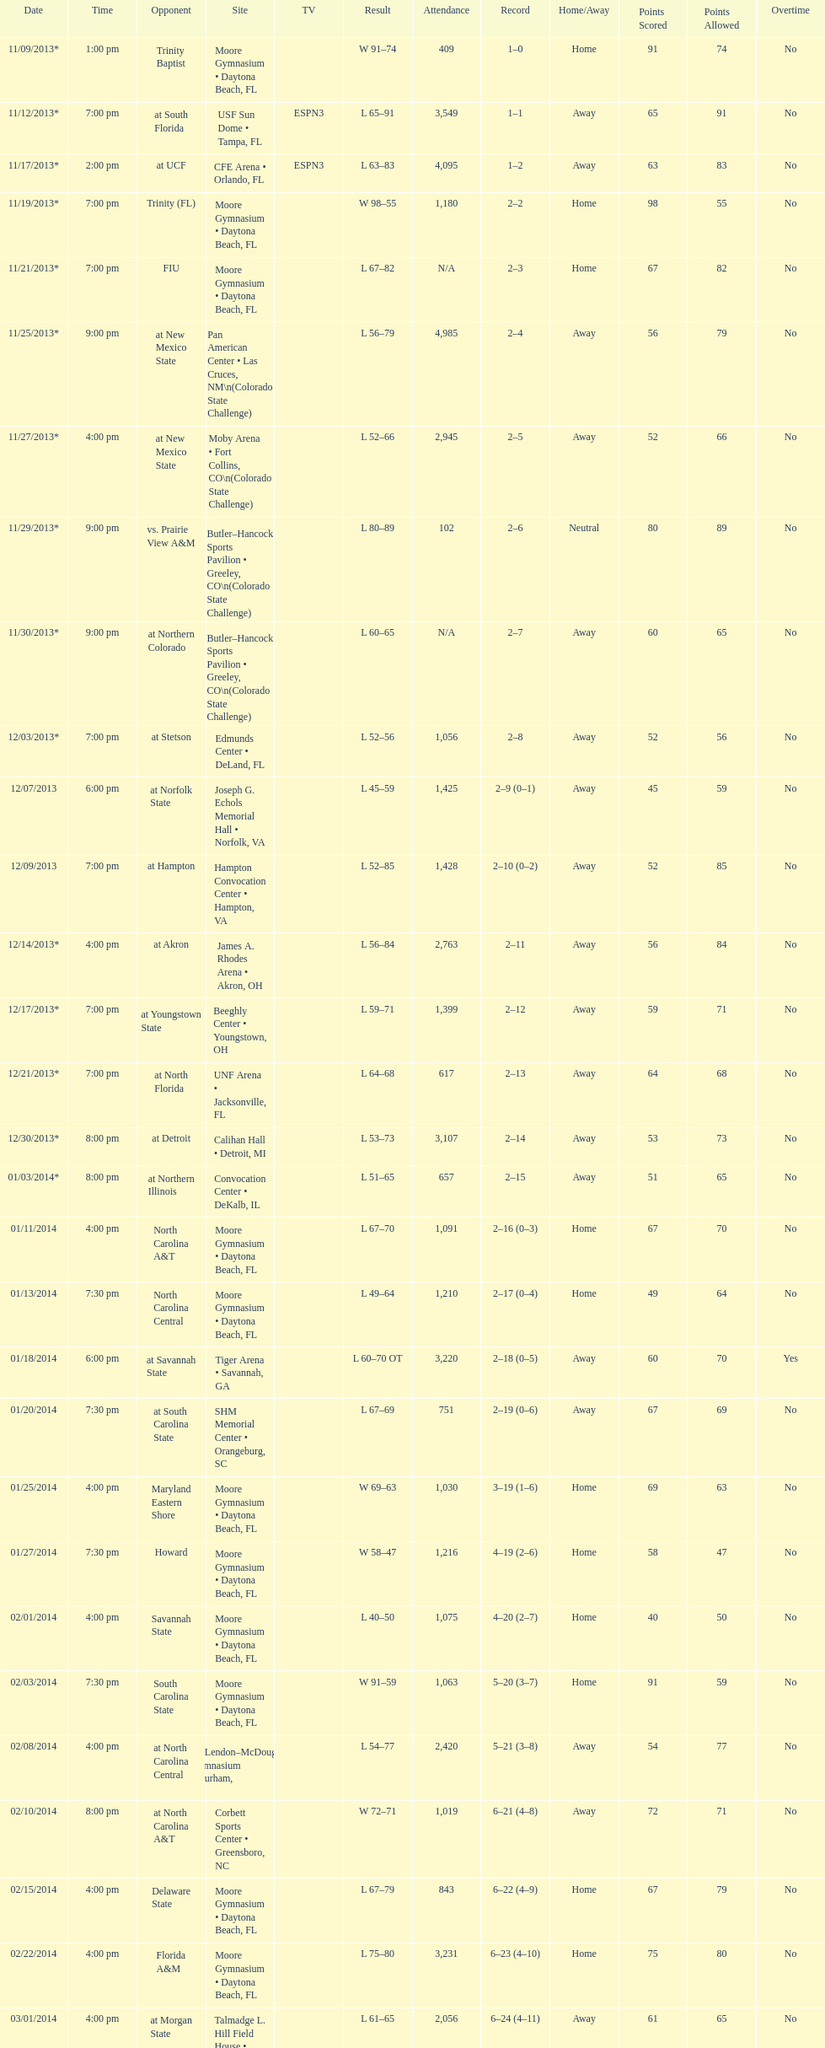Which game was later at night, fiu or northern colorado? Northern Colorado. 